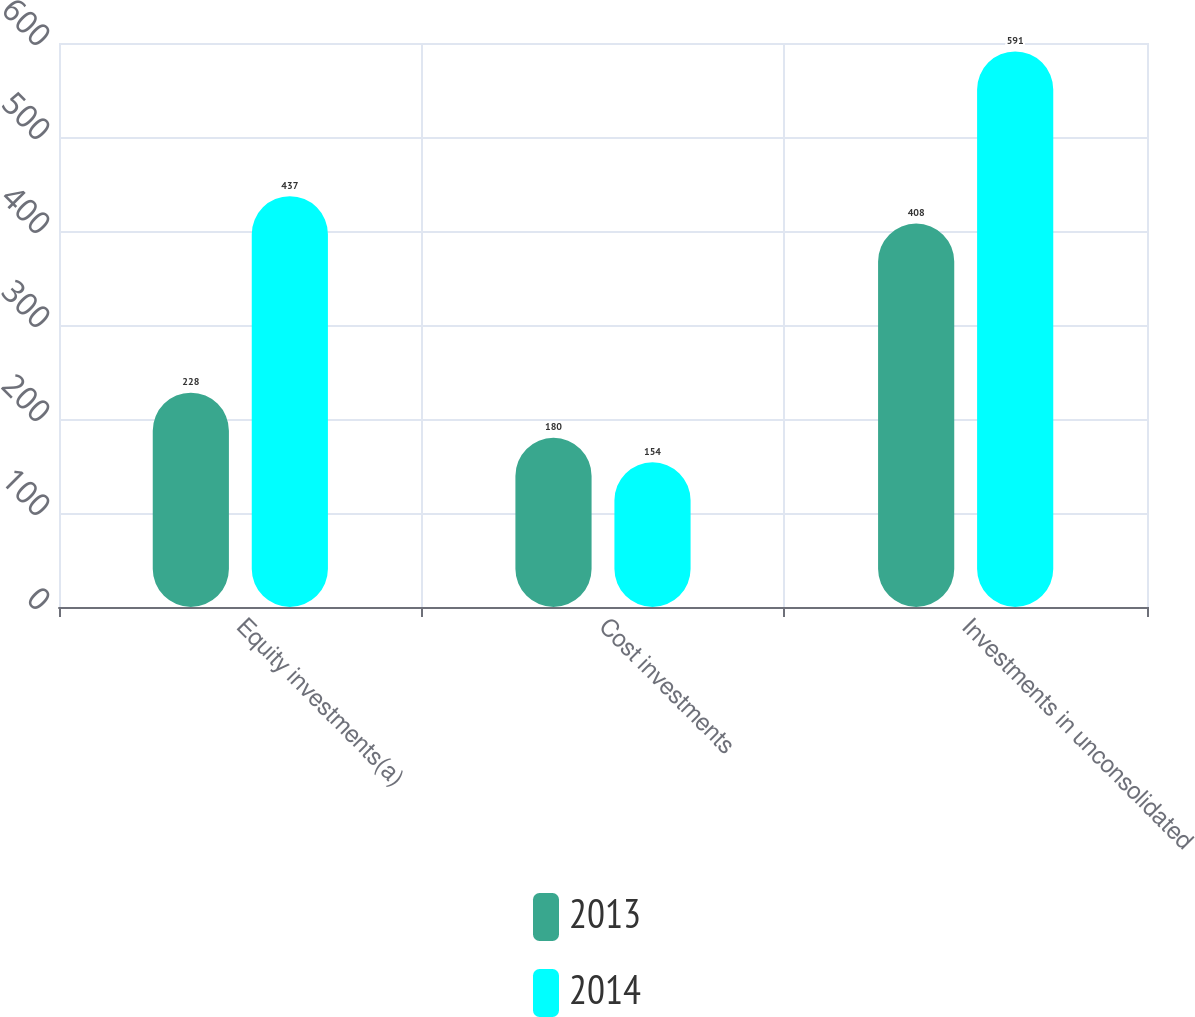Convert chart to OTSL. <chart><loc_0><loc_0><loc_500><loc_500><stacked_bar_chart><ecel><fcel>Equity investments(a)<fcel>Cost investments<fcel>Investments in unconsolidated<nl><fcel>2013<fcel>228<fcel>180<fcel>408<nl><fcel>2014<fcel>437<fcel>154<fcel>591<nl></chart> 